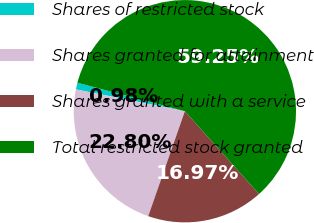<chart> <loc_0><loc_0><loc_500><loc_500><pie_chart><fcel>Shares of restricted stock<fcel>Shares granted for attainment<fcel>Shares granted with a service<fcel>Total restricted stock granted<nl><fcel>0.98%<fcel>22.8%<fcel>16.97%<fcel>59.25%<nl></chart> 